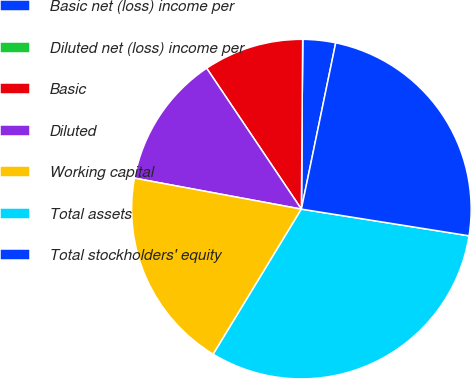<chart> <loc_0><loc_0><loc_500><loc_500><pie_chart><fcel>Basic net (loss) income per<fcel>Diluted net (loss) income per<fcel>Basic<fcel>Diluted<fcel>Working capital<fcel>Total assets<fcel>Total stockholders' equity<nl><fcel>3.12%<fcel>0.0%<fcel>9.54%<fcel>12.66%<fcel>19.23%<fcel>31.18%<fcel>24.27%<nl></chart> 